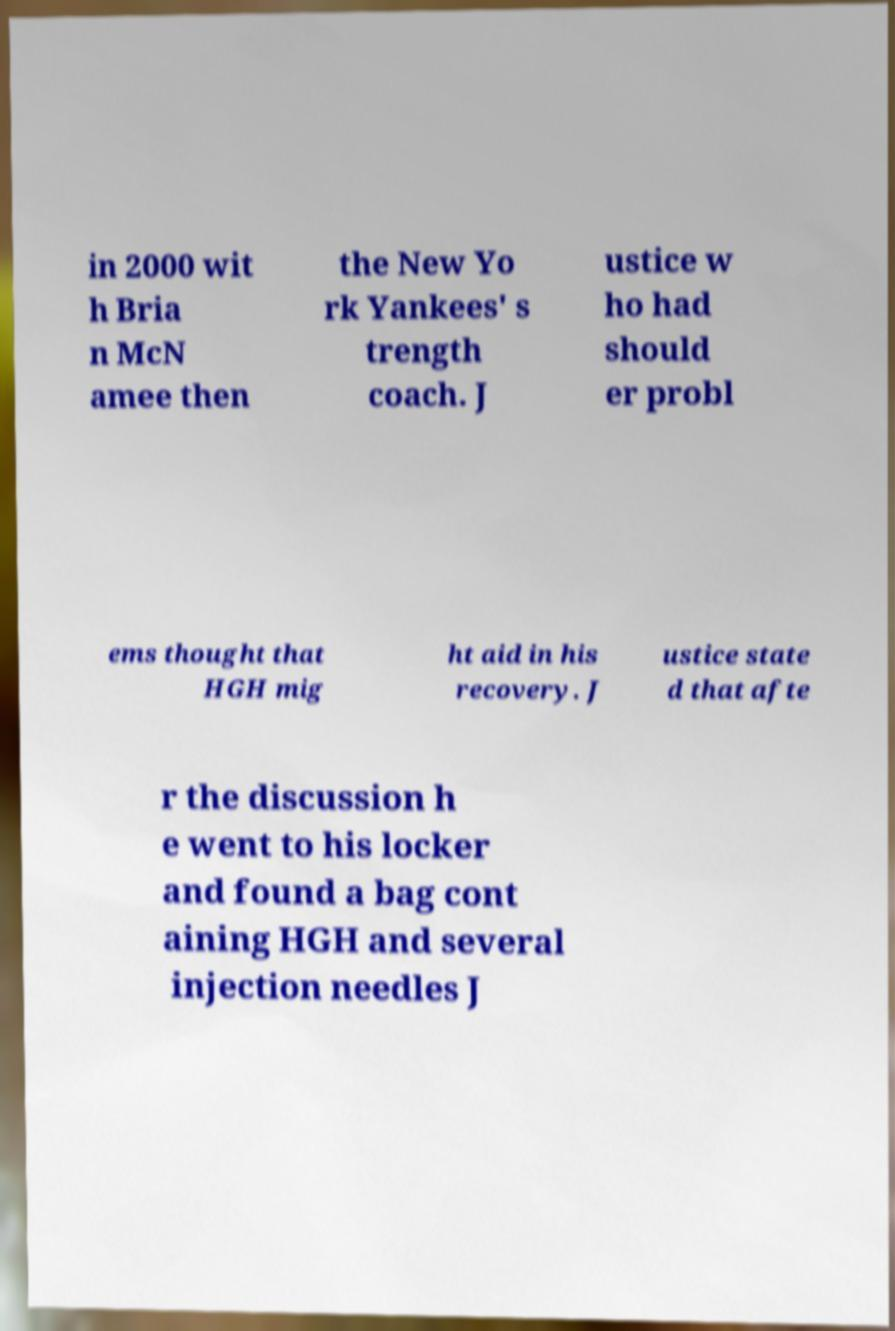Can you read and provide the text displayed in the image?This photo seems to have some interesting text. Can you extract and type it out for me? in 2000 wit h Bria n McN amee then the New Yo rk Yankees' s trength coach. J ustice w ho had should er probl ems thought that HGH mig ht aid in his recovery. J ustice state d that afte r the discussion h e went to his locker and found a bag cont aining HGH and several injection needles J 